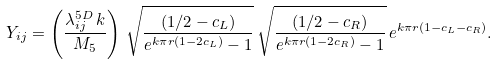<formula> <loc_0><loc_0><loc_500><loc_500>Y _ { i j } = \left ( \frac { \lambda _ { i j } ^ { 5 D } \, k } { M _ { 5 } } \right ) \, \sqrt { \frac { ( 1 / 2 - c _ { L } ) } { e ^ { k \pi r ( 1 - 2 c _ { L } ) } - 1 } } \, \sqrt { \frac { ( 1 / 2 - c _ { R } ) } { e ^ { k \pi r ( 1 - 2 c _ { R } ) } - 1 } } \, e ^ { k \pi r ( 1 - c _ { L } - c _ { R } ) } .</formula> 